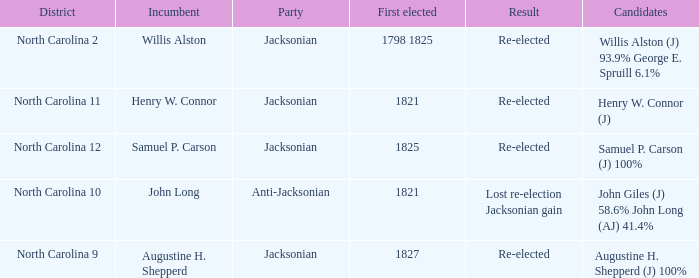Name the total number of party for willis alston (j) 93.9% george e. spruill 6.1% 1.0. 